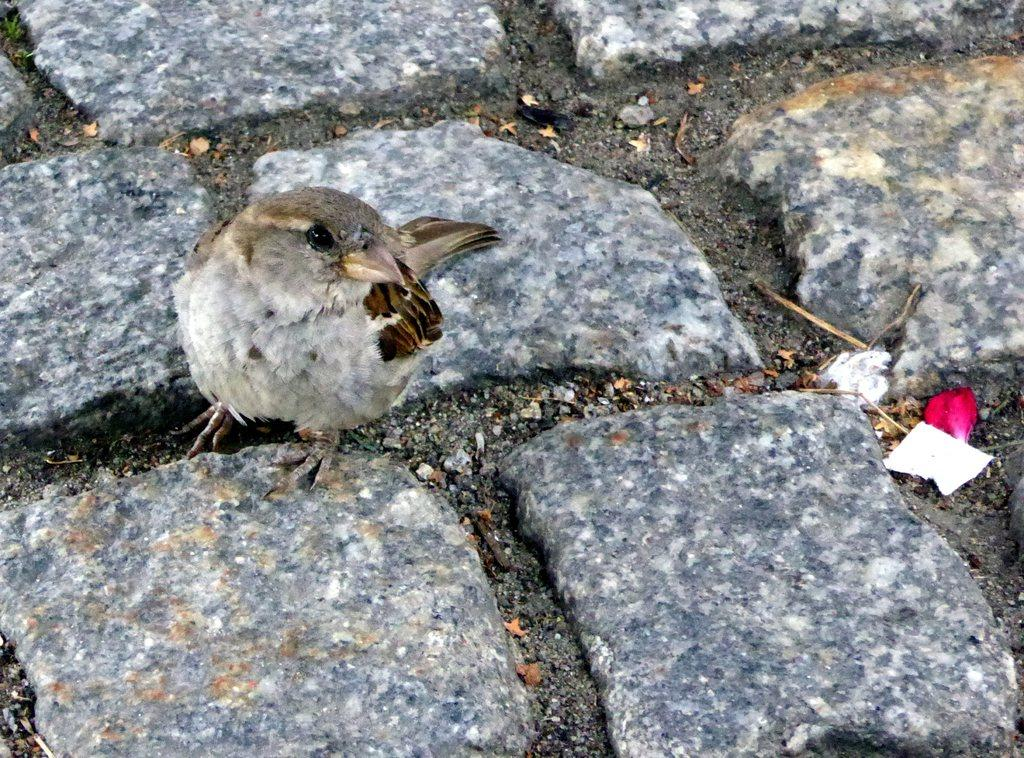What type of animal can be seen in the image? There is a bird in the image. What else is present in the image besides the bird? There are dust particles on rock stones in the image. What type of twig is the bird using to build its nest in the image? There is no nest or twig present in the image; it only features a bird and dust particles on rock stones. 